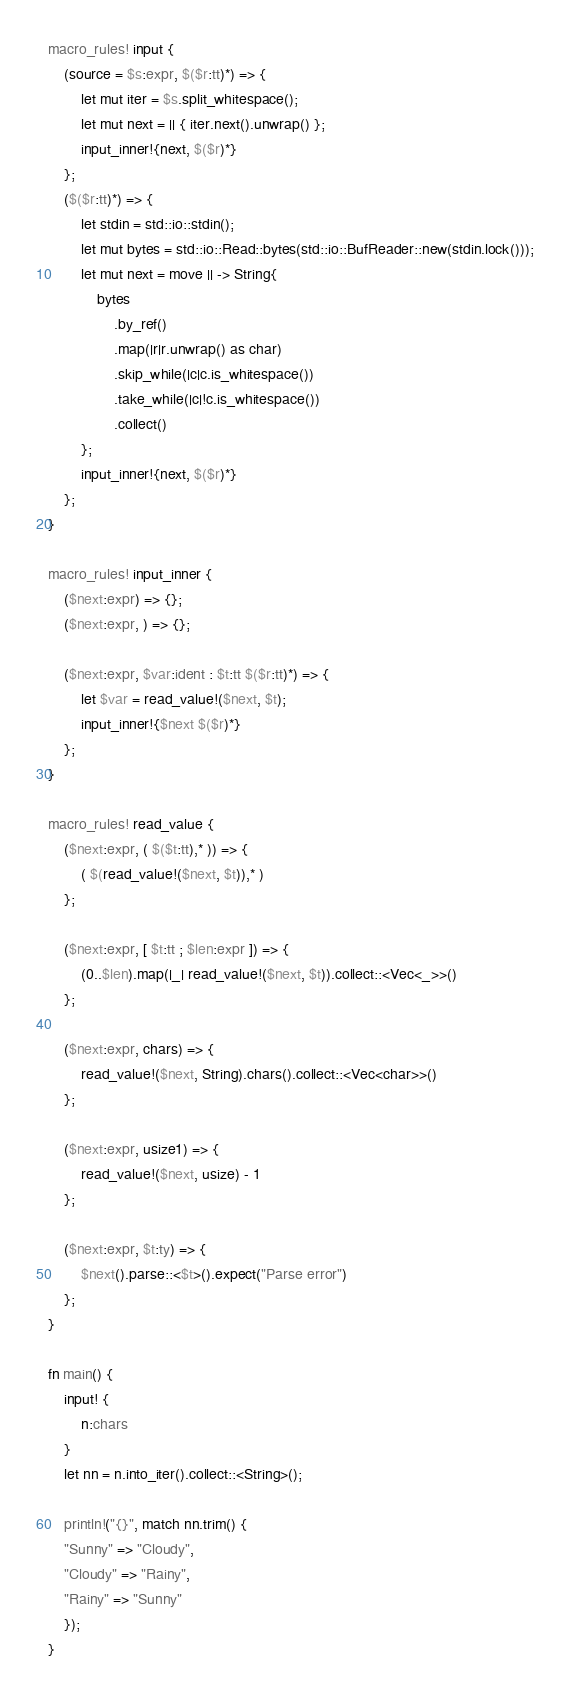Convert code to text. <code><loc_0><loc_0><loc_500><loc_500><_Rust_>macro_rules! input {
    (source = $s:expr, $($r:tt)*) => {
        let mut iter = $s.split_whitespace();
        let mut next = || { iter.next().unwrap() };
        input_inner!{next, $($r)*}
    };
    ($($r:tt)*) => {
        let stdin = std::io::stdin();
        let mut bytes = std::io::Read::bytes(std::io::BufReader::new(stdin.lock()));
        let mut next = move || -> String{
            bytes
                .by_ref()
                .map(|r|r.unwrap() as char)
                .skip_while(|c|c.is_whitespace())
                .take_while(|c|!c.is_whitespace())
                .collect()
        };
        input_inner!{next, $($r)*}
    };
}

macro_rules! input_inner {
    ($next:expr) => {};
    ($next:expr, ) => {};

    ($next:expr, $var:ident : $t:tt $($r:tt)*) => {
        let $var = read_value!($next, $t);
        input_inner!{$next $($r)*}
    };
}

macro_rules! read_value {
    ($next:expr, ( $($t:tt),* )) => {
        ( $(read_value!($next, $t)),* )
    };

    ($next:expr, [ $t:tt ; $len:expr ]) => {
        (0..$len).map(|_| read_value!($next, $t)).collect::<Vec<_>>()
    };

    ($next:expr, chars) => {
        read_value!($next, String).chars().collect::<Vec<char>>()
    };

    ($next:expr, usize1) => {
        read_value!($next, usize) - 1
    };

    ($next:expr, $t:ty) => {
        $next().parse::<$t>().expect("Parse error")
    };
}

fn main() {
    input! {
    	n:chars
    }
    let nn = n.into_iter().collect::<String>();
    
    println!("{}", match nn.trim() {
    "Sunny" => "Cloudy",
    "Cloudy" => "Rainy",
    "Rainy" => "Sunny"
    });
}</code> 